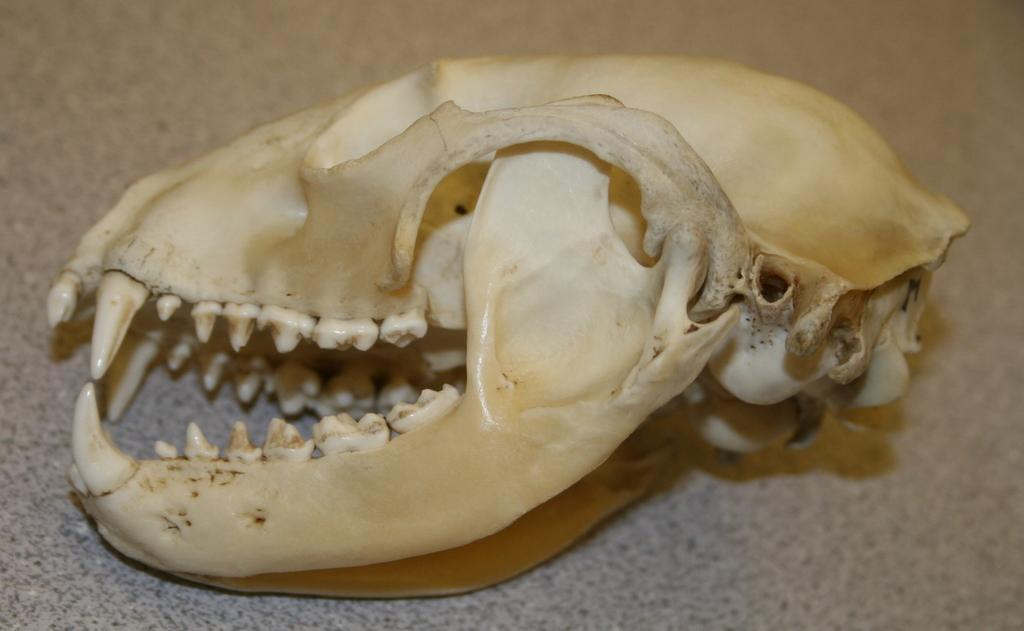What is the main subject of the image? The main subject of the image is a skull. To which creature does the skull belong? The skull belongs to some creature, but it is not specified in the image. Where is the skull located in the image? The skull is on the ground in the image. What type of rhythm does the scarecrow have in the image? There is no scarecrow present in the image, so it is not possible to determine its rhythm. 